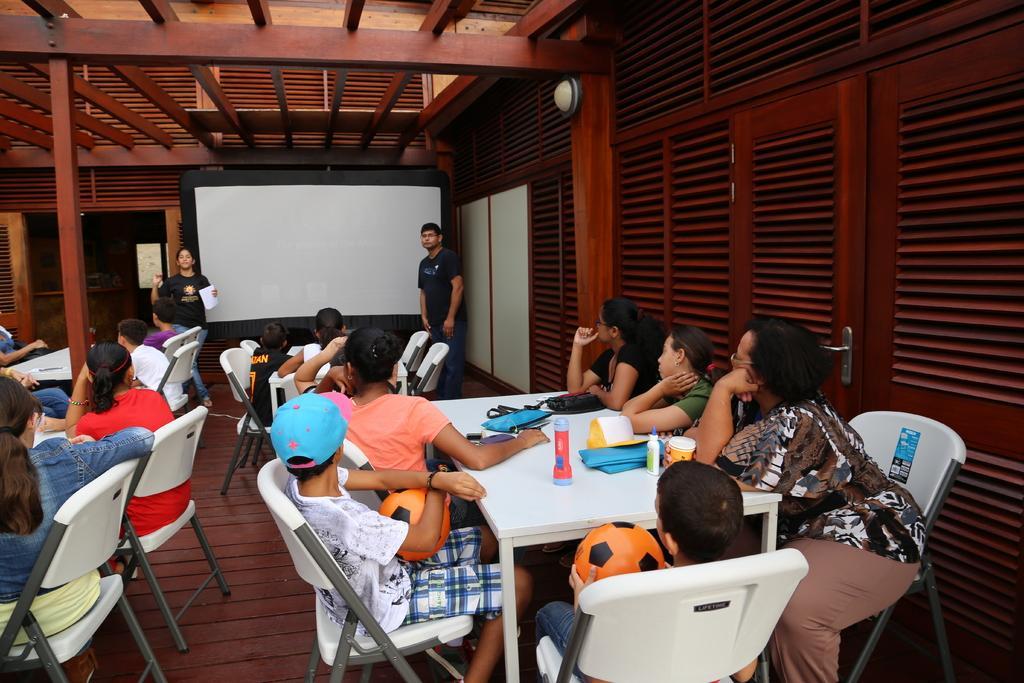Describe this image in one or two sentences. Here we can see a group of people sitting on chairs with tables in front of them and there are couple of people standing and speaking to them and there is a board in the middle and we can see in the front children holding footballs in the hand and there are doors present 